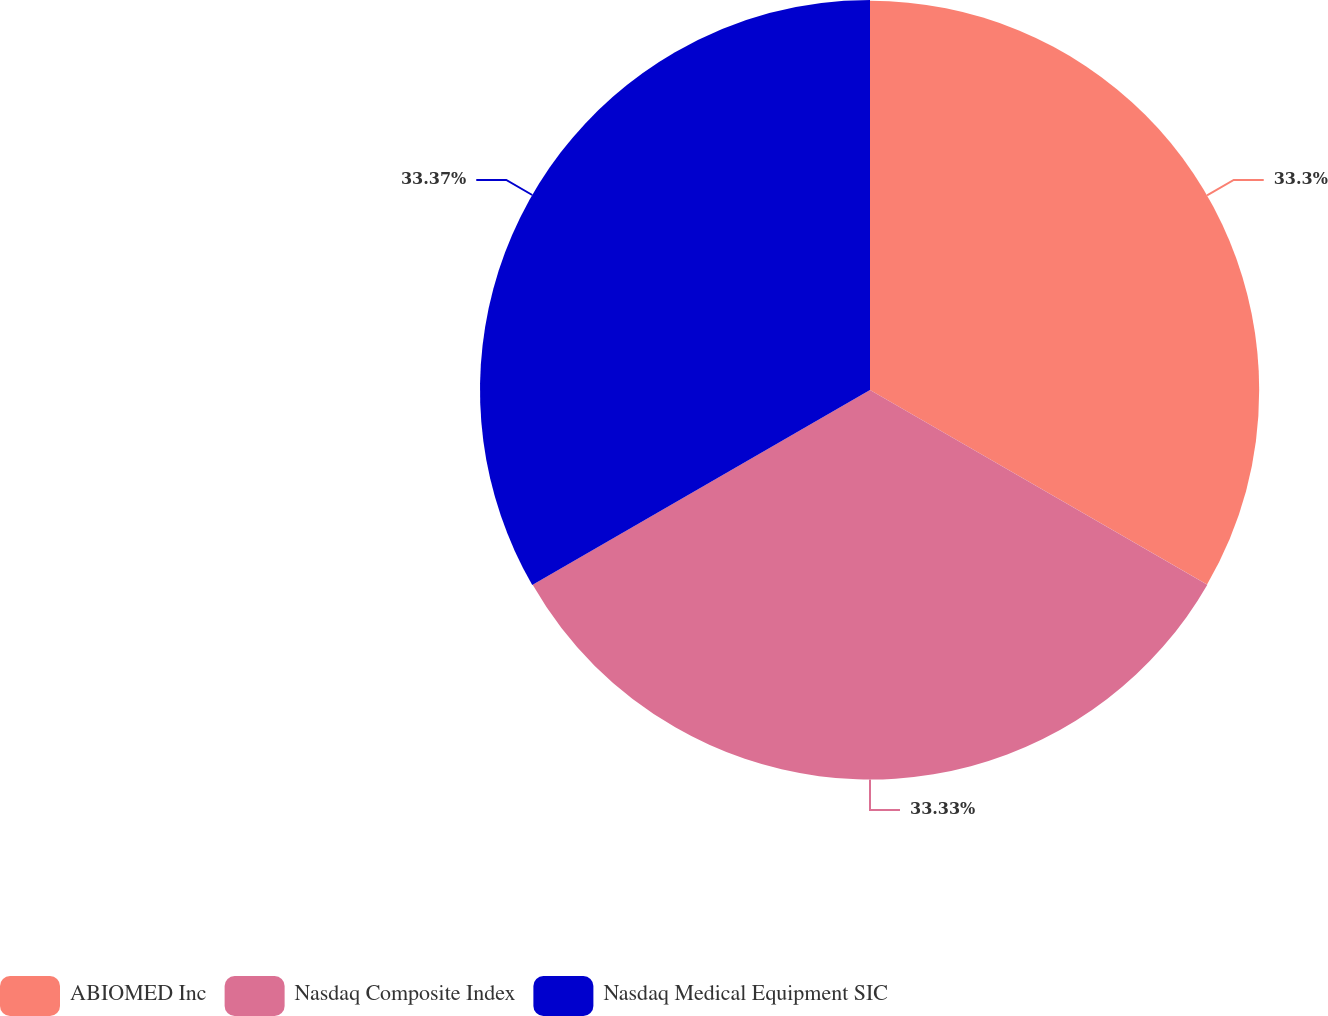<chart> <loc_0><loc_0><loc_500><loc_500><pie_chart><fcel>ABIOMED Inc<fcel>Nasdaq Composite Index<fcel>Nasdaq Medical Equipment SIC<nl><fcel>33.3%<fcel>33.33%<fcel>33.37%<nl></chart> 